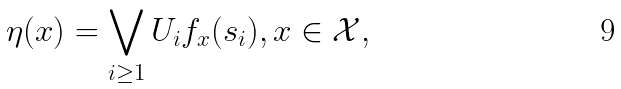Convert formula to latex. <formula><loc_0><loc_0><loc_500><loc_500>\eta ( x ) = \bigvee _ { i \geq 1 } U _ { i } f _ { x } ( s _ { i } ) , x \in \mathcal { X } ,</formula> 